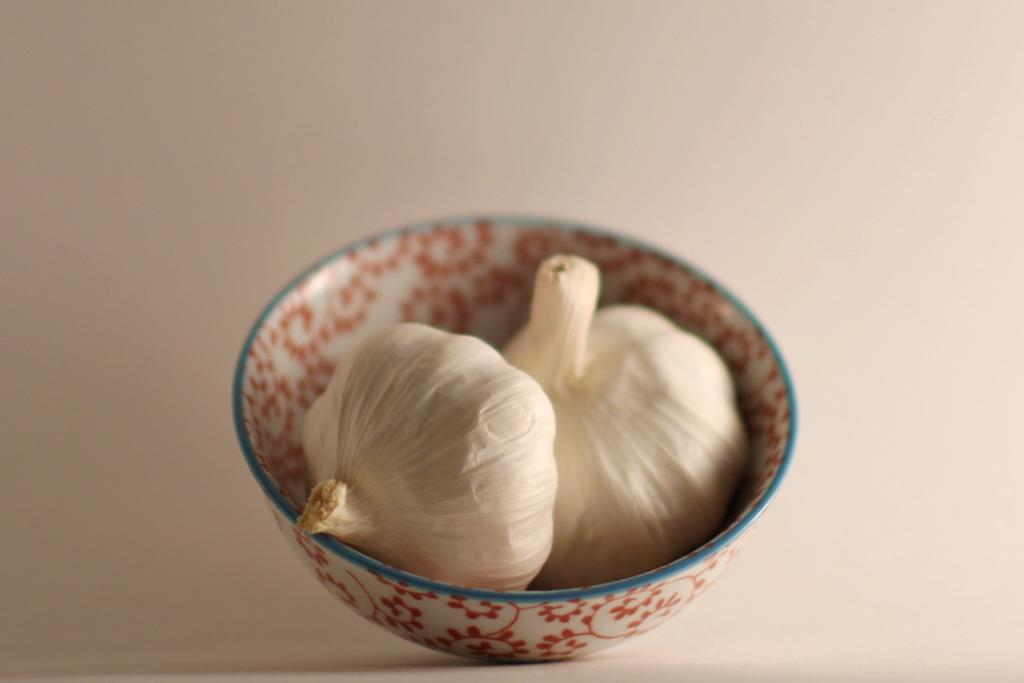What is the main subject of the image? The main subject of the image is two garlic. Where are the garlic located in the image? The garlic are in a bowl. What color is the background of the image? The background of the image appears to be white in color. How many baseballs are visible in the image? There are no baseballs present in the image. How many legs can be seen supporting the garlic in the image? The garlic are in a bowl, and there are no legs visible in the image. 